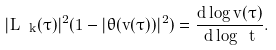<formula> <loc_0><loc_0><loc_500><loc_500>| L _ { \ k } ( \tau ) | ^ { 2 } ( 1 - | \theta ( v ( \tau ) ) | ^ { 2 } ) = \frac { d \log v ( \tau ) } { d \log \ t } .</formula> 